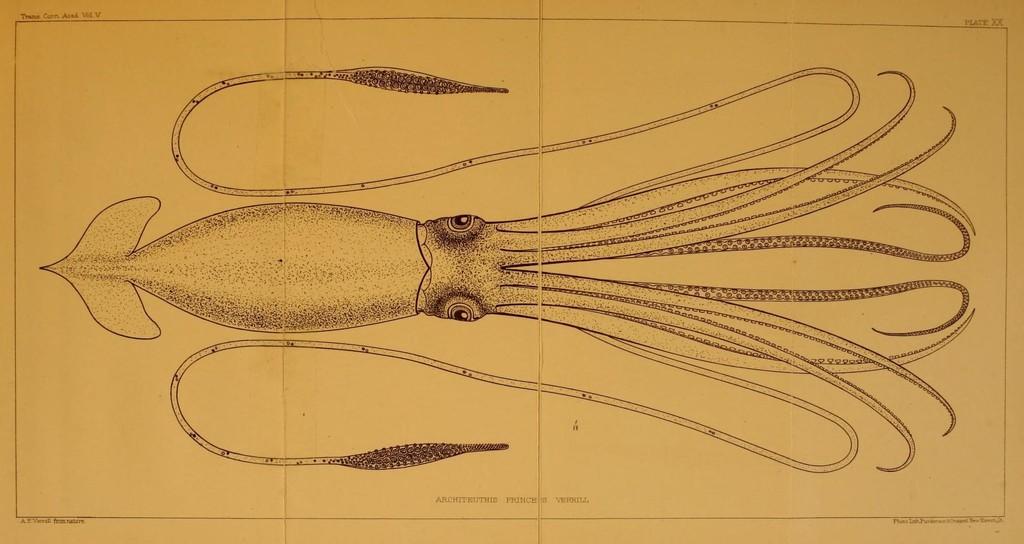Describe this image in one or two sentences. In this image there is the drawing of an octopus. 